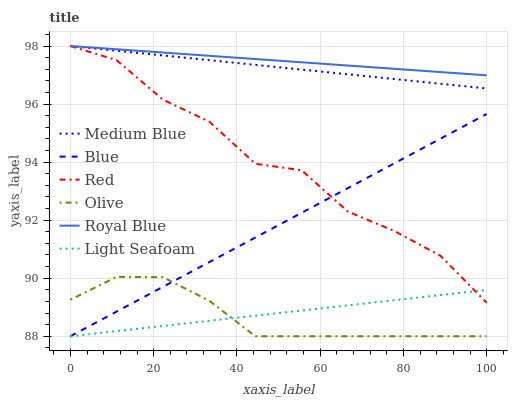Does Olive have the minimum area under the curve?
Answer yes or no. Yes. Does Royal Blue have the maximum area under the curve?
Answer yes or no. Yes. Does Medium Blue have the minimum area under the curve?
Answer yes or no. No. Does Medium Blue have the maximum area under the curve?
Answer yes or no. No. Is Royal Blue the smoothest?
Answer yes or no. Yes. Is Red the roughest?
Answer yes or no. Yes. Is Medium Blue the smoothest?
Answer yes or no. No. Is Medium Blue the roughest?
Answer yes or no. No. Does Blue have the lowest value?
Answer yes or no. Yes. Does Medium Blue have the lowest value?
Answer yes or no. No. Does Red have the highest value?
Answer yes or no. Yes. Does Olive have the highest value?
Answer yes or no. No. Is Blue less than Royal Blue?
Answer yes or no. Yes. Is Royal Blue greater than Olive?
Answer yes or no. Yes. Does Medium Blue intersect Royal Blue?
Answer yes or no. Yes. Is Medium Blue less than Royal Blue?
Answer yes or no. No. Is Medium Blue greater than Royal Blue?
Answer yes or no. No. Does Blue intersect Royal Blue?
Answer yes or no. No. 